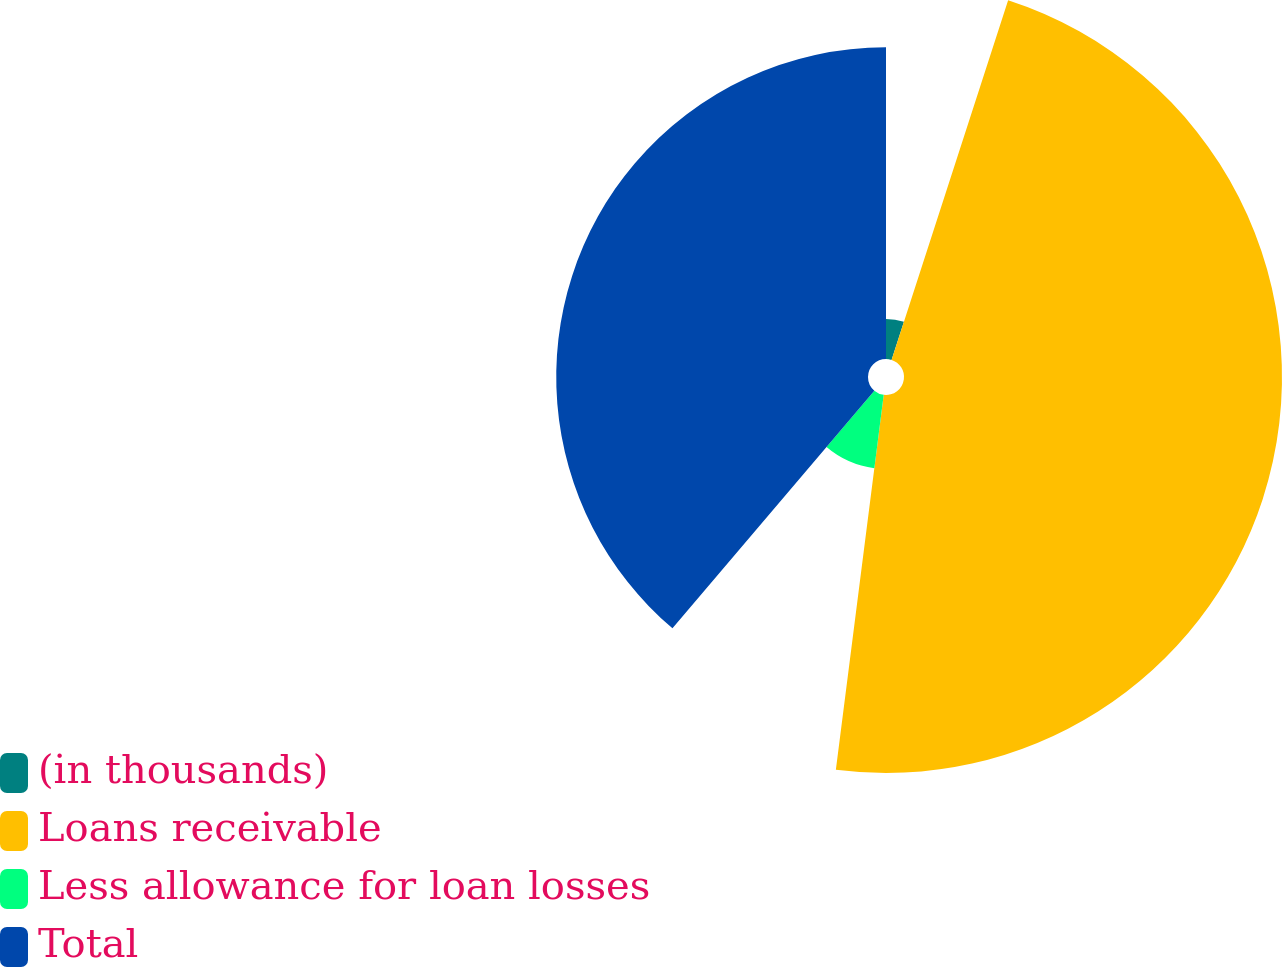Convert chart to OTSL. <chart><loc_0><loc_0><loc_500><loc_500><pie_chart><fcel>(in thousands)<fcel>Loans receivable<fcel>Less allowance for loan losses<fcel>Total<nl><fcel>4.99%<fcel>47.03%<fcel>9.19%<fcel>38.79%<nl></chart> 